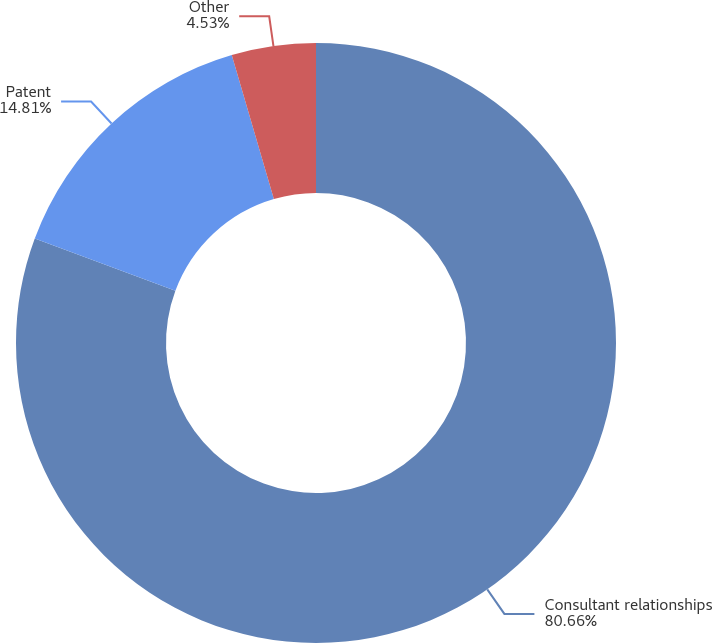<chart> <loc_0><loc_0><loc_500><loc_500><pie_chart><fcel>Consultant relationships<fcel>Patent<fcel>Other<nl><fcel>80.66%<fcel>14.81%<fcel>4.53%<nl></chart> 